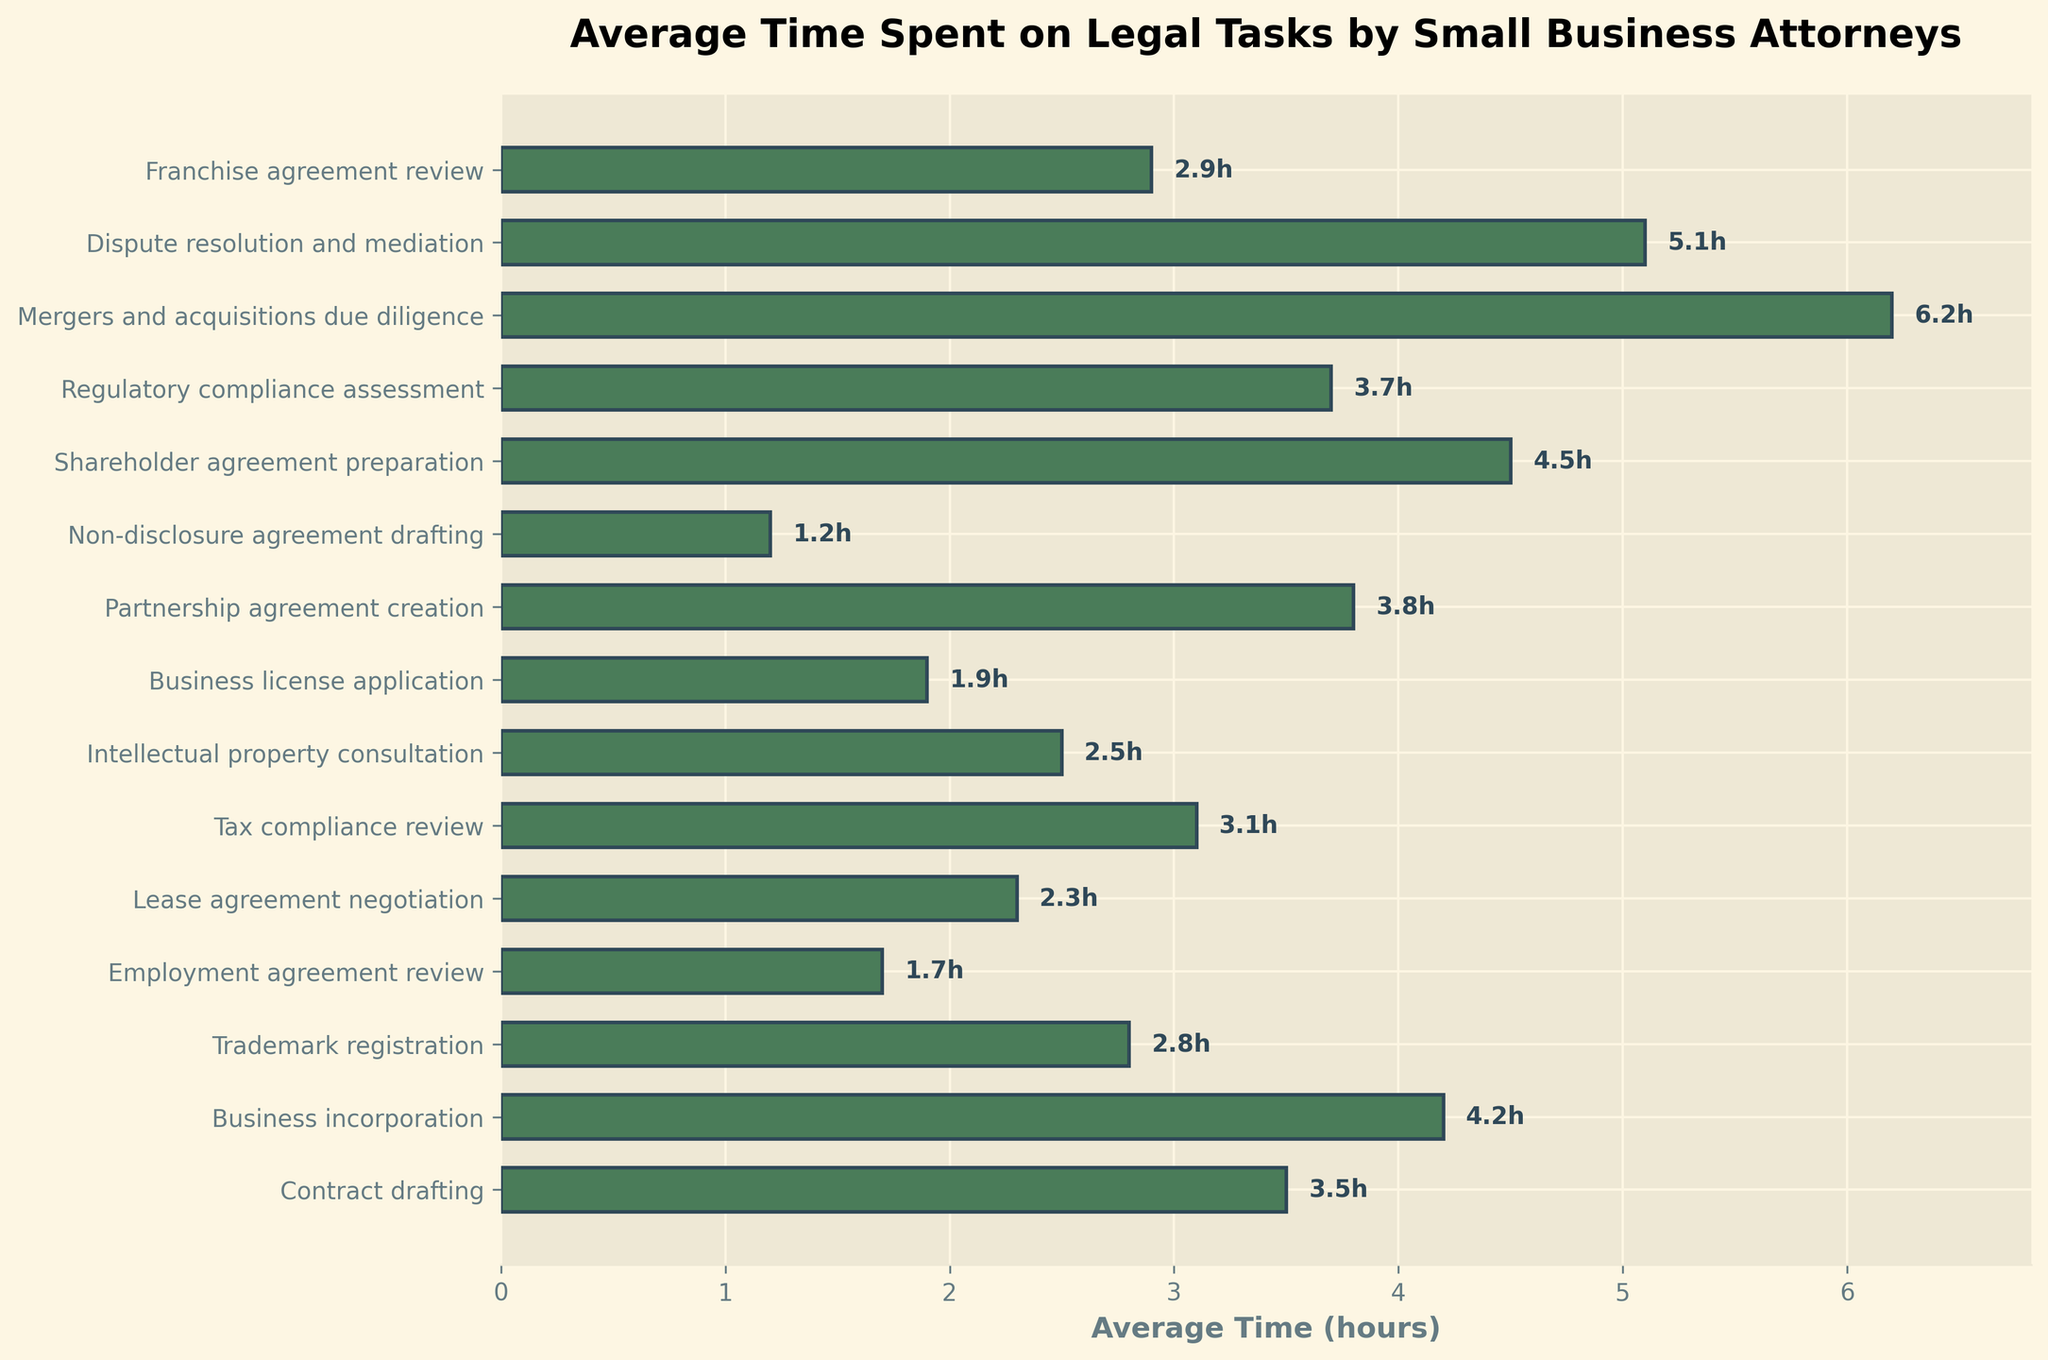What's the task with the longest average time? Locate the bar representing the longest duration visually. "Mergers and acquisitions due diligence" has the longest bar at 6.2 hours.
Answer: Mergers and acquisitions due diligence How many tasks take on average more than 4 hours? Identify and count the bars that extend beyond the 4-hour mark on the x-axis. There are four: "Business incorporation," "Partnership agreement creation," "Shareholder agreement preparation," and "Mergers and acquisitions due diligence."
Answer: 4 tasks Which task takes exactly 2.8 hours on average? Look for the bar labeled with "2.8h." The corresponding task is "Trademark registration."
Answer: Trademark registration What is the sum of the average times for "Contract drafting" and "Tax compliance review"? Add the average times: 3.5 hours for "Contract drafting" and 3.1 hours for "Tax compliance review" (3.5 + 3.1).
Answer: 6.6 hours Is the average time for "Employee agreement review" more or less than that for "Lease agreement negotiation"? Compare the lengths of the respective bars: "Employee agreement review" at 1.7 hours and "Lease agreement negotiation" at 2.3 hours.
Answer: Less What is the difference in average time between "Intellectual property consultation" and "Business license application"? Subtract the smaller value from the larger: 2.5 hours for "Intellectual property consultation" and 1.9 hours for "Business license application" (2.5 - 1.9).
Answer: 0.6 hours Which tasks take less than 2 hours on average? Identify and list the tasks with bars that fall under the 2-hour mark on the x-axis. These tasks are "Non-disclosure agreement drafting" and "Business license application."
Answer: Non-disclosure agreement drafting, Business license application What is the average time across all tasks? Sum the average times for all tasks and divide by the number of tasks. Total sum is 49.3 hours, divided by 15 tasks (49.3 / 15).
Answer: 3.29 hours Which task takes one-third the time of "Mergers and acquisitions due diligence"? Calculate one-third of the time for "Mergers and acquisitions due diligence" (6.2 / 3 = 2.07 hours). The closest task to this duration is "Business license application" at 1.9 hours.
Answer: Business license application 